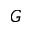Convert formula to latex. <formula><loc_0><loc_0><loc_500><loc_500>G</formula> 